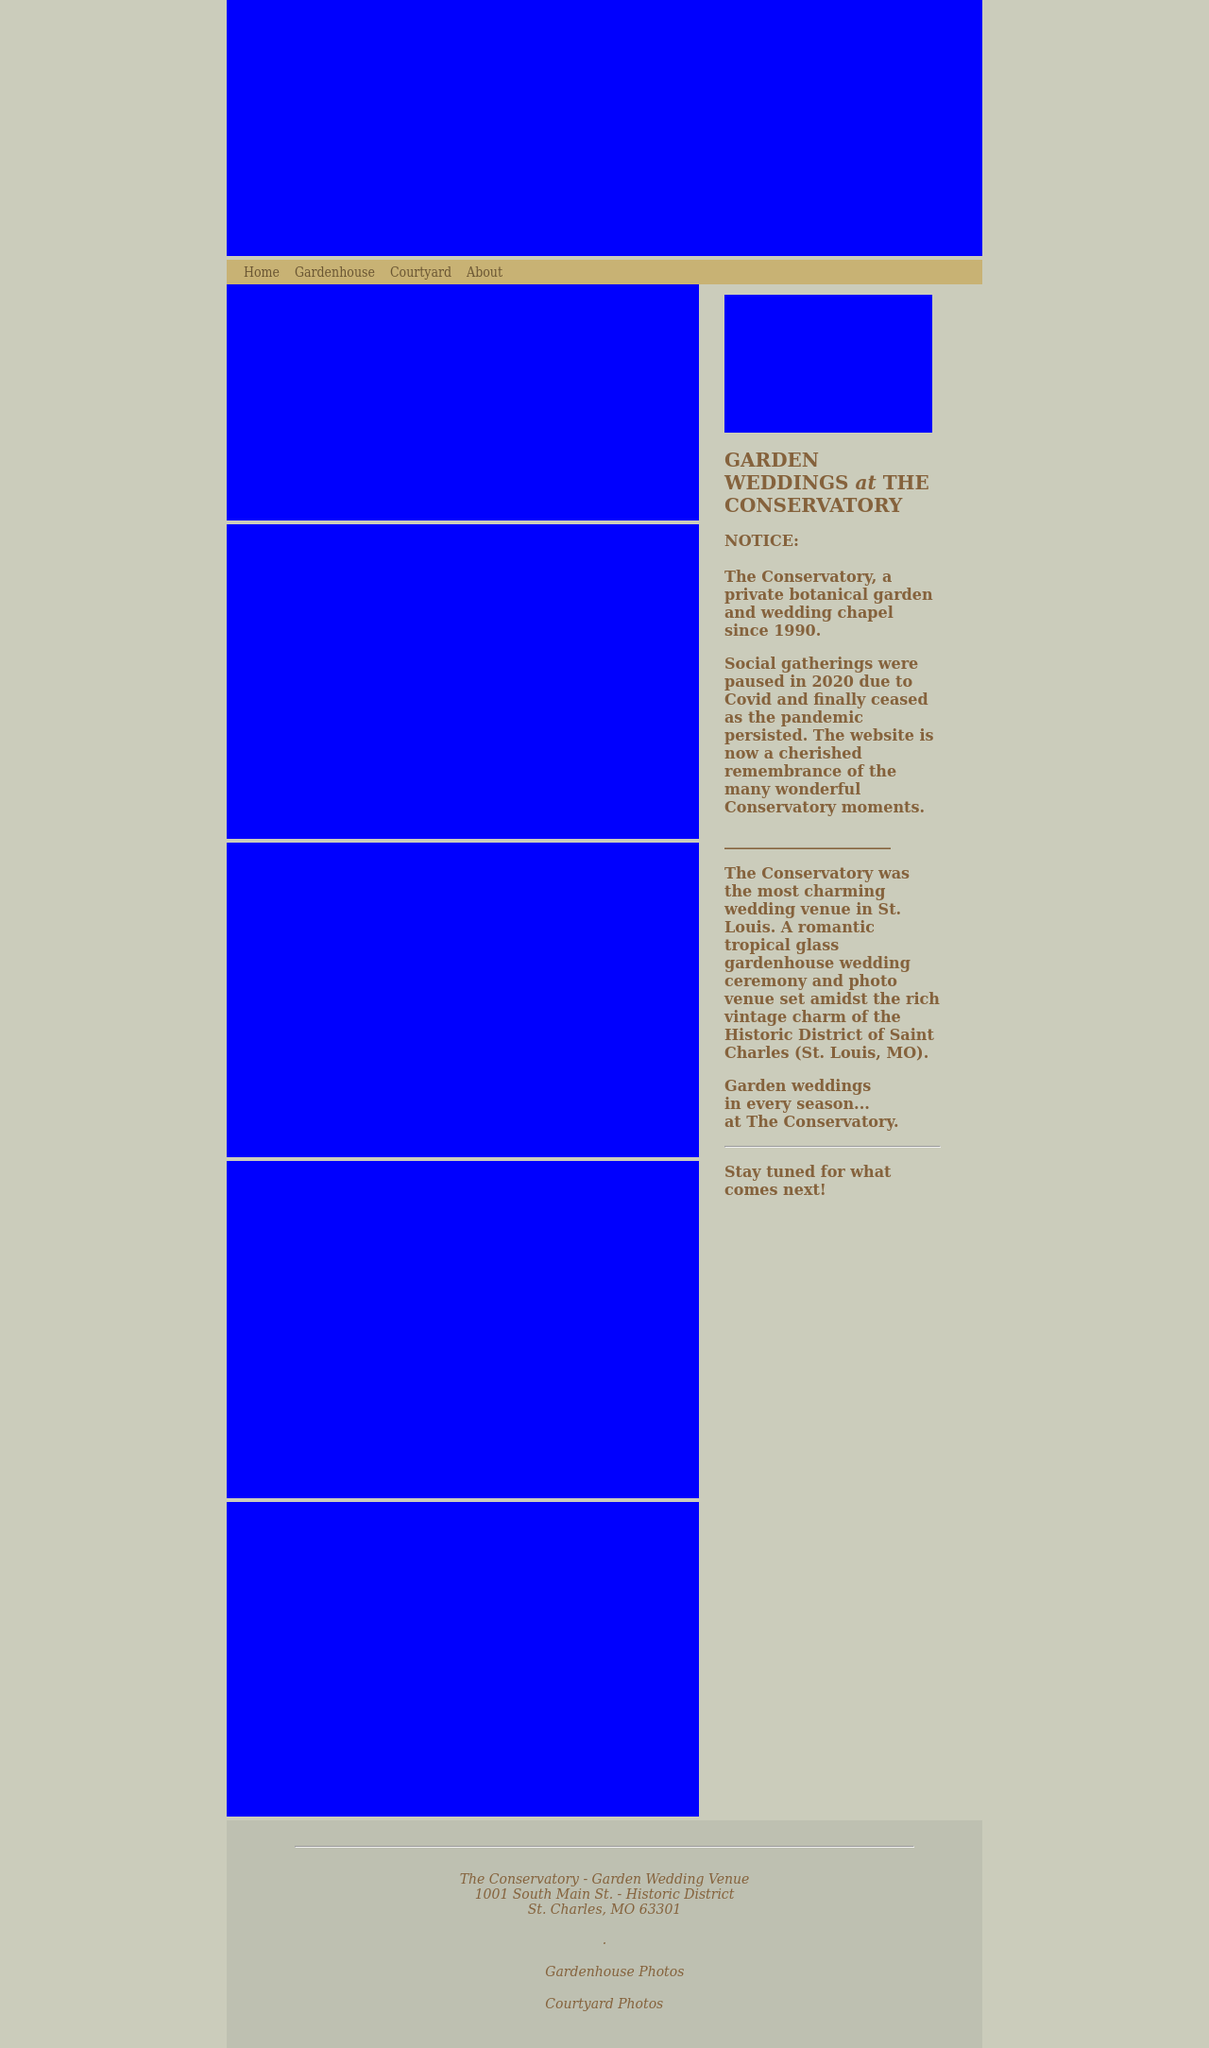Can you describe some of the unique features of this venue that make it ideal for wedding photography? One of the standout features of The Conservatory is its gorgeous glass gardenhouse, which provides a luminous, natural light setting perfect for photography. The surrounding historic architecture and the intricate landscape designs, including quaint pathways and ornate fountains, offer diverse and captivating backdrops for wedding photos. What types of wedding ceremonies are typically held here? The venue is versatile, hosting a range of ceremonies from traditional ones to more modern, personalized celebrations. It especially caters to intimate gatherings, emphasizing the natural beauty and secluded serenity of the garden setting. 